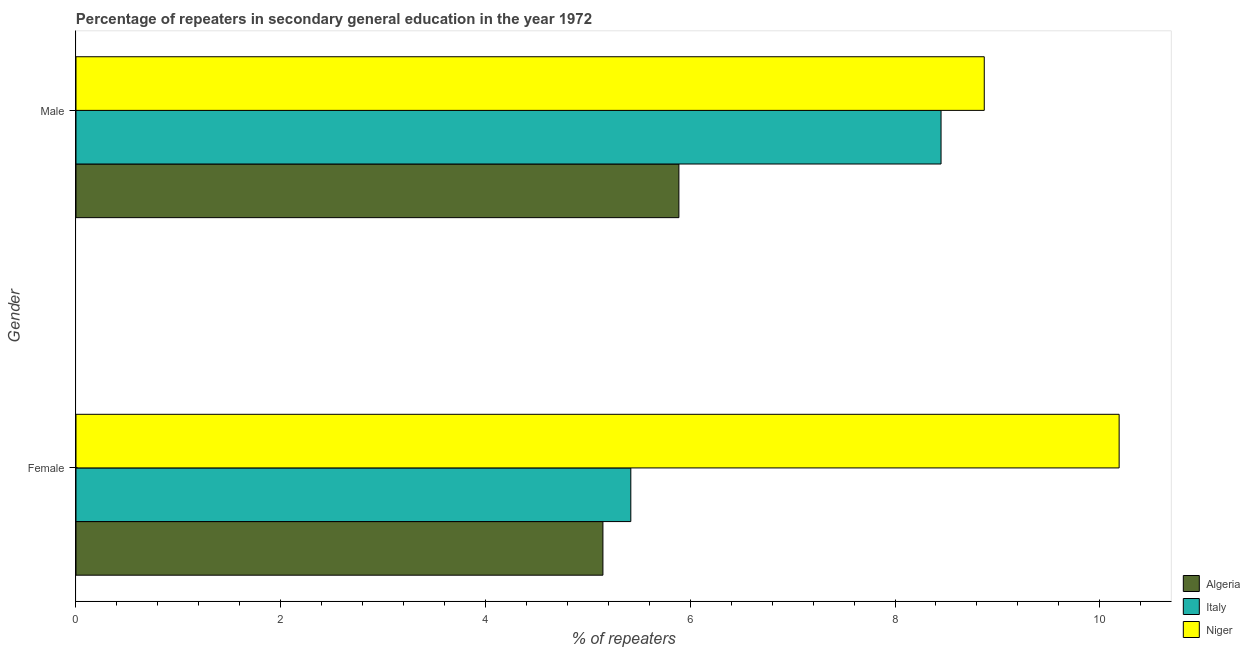Are the number of bars on each tick of the Y-axis equal?
Ensure brevity in your answer.  Yes. How many bars are there on the 1st tick from the top?
Give a very brief answer. 3. What is the percentage of male repeaters in Algeria?
Provide a succinct answer. 5.89. Across all countries, what is the maximum percentage of female repeaters?
Offer a very short reply. 10.19. Across all countries, what is the minimum percentage of male repeaters?
Keep it short and to the point. 5.89. In which country was the percentage of male repeaters maximum?
Keep it short and to the point. Niger. In which country was the percentage of male repeaters minimum?
Provide a short and direct response. Algeria. What is the total percentage of male repeaters in the graph?
Your answer should be compact. 23.21. What is the difference between the percentage of female repeaters in Niger and that in Italy?
Keep it short and to the point. 4.77. What is the difference between the percentage of female repeaters in Niger and the percentage of male repeaters in Italy?
Your answer should be compact. 1.74. What is the average percentage of female repeaters per country?
Your answer should be very brief. 6.92. What is the difference between the percentage of male repeaters and percentage of female repeaters in Italy?
Make the answer very short. 3.03. In how many countries, is the percentage of male repeaters greater than 0.8 %?
Offer a very short reply. 3. What is the ratio of the percentage of female repeaters in Niger to that in Italy?
Keep it short and to the point. 1.88. Is the percentage of female repeaters in Algeria less than that in Niger?
Your response must be concise. Yes. In how many countries, is the percentage of male repeaters greater than the average percentage of male repeaters taken over all countries?
Ensure brevity in your answer.  2. What does the 2nd bar from the top in Female represents?
Ensure brevity in your answer.  Italy. What does the 1st bar from the bottom in Male represents?
Keep it short and to the point. Algeria. How many countries are there in the graph?
Your answer should be very brief. 3. Does the graph contain any zero values?
Offer a very short reply. No. How many legend labels are there?
Your answer should be very brief. 3. How are the legend labels stacked?
Make the answer very short. Vertical. What is the title of the graph?
Make the answer very short. Percentage of repeaters in secondary general education in the year 1972. Does "Switzerland" appear as one of the legend labels in the graph?
Your answer should be very brief. No. What is the label or title of the X-axis?
Provide a succinct answer. % of repeaters. What is the % of repeaters in Algeria in Female?
Your answer should be compact. 5.15. What is the % of repeaters of Italy in Female?
Keep it short and to the point. 5.42. What is the % of repeaters of Niger in Female?
Give a very brief answer. 10.19. What is the % of repeaters of Algeria in Male?
Keep it short and to the point. 5.89. What is the % of repeaters in Italy in Male?
Keep it short and to the point. 8.45. What is the % of repeaters of Niger in Male?
Give a very brief answer. 8.87. Across all Gender, what is the maximum % of repeaters in Algeria?
Your response must be concise. 5.89. Across all Gender, what is the maximum % of repeaters in Italy?
Ensure brevity in your answer.  8.45. Across all Gender, what is the maximum % of repeaters of Niger?
Ensure brevity in your answer.  10.19. Across all Gender, what is the minimum % of repeaters of Algeria?
Keep it short and to the point. 5.15. Across all Gender, what is the minimum % of repeaters in Italy?
Provide a short and direct response. 5.42. Across all Gender, what is the minimum % of repeaters of Niger?
Offer a very short reply. 8.87. What is the total % of repeaters of Algeria in the graph?
Your answer should be compact. 11.04. What is the total % of repeaters of Italy in the graph?
Make the answer very short. 13.87. What is the total % of repeaters of Niger in the graph?
Offer a terse response. 19.06. What is the difference between the % of repeaters of Algeria in Female and that in Male?
Your response must be concise. -0.74. What is the difference between the % of repeaters of Italy in Female and that in Male?
Your answer should be compact. -3.03. What is the difference between the % of repeaters of Niger in Female and that in Male?
Provide a short and direct response. 1.32. What is the difference between the % of repeaters of Algeria in Female and the % of repeaters of Italy in Male?
Give a very brief answer. -3.3. What is the difference between the % of repeaters in Algeria in Female and the % of repeaters in Niger in Male?
Make the answer very short. -3.72. What is the difference between the % of repeaters of Italy in Female and the % of repeaters of Niger in Male?
Your answer should be compact. -3.45. What is the average % of repeaters of Algeria per Gender?
Provide a short and direct response. 5.52. What is the average % of repeaters in Italy per Gender?
Provide a short and direct response. 6.93. What is the average % of repeaters of Niger per Gender?
Give a very brief answer. 9.53. What is the difference between the % of repeaters in Algeria and % of repeaters in Italy in Female?
Your answer should be compact. -0.27. What is the difference between the % of repeaters of Algeria and % of repeaters of Niger in Female?
Give a very brief answer. -5.04. What is the difference between the % of repeaters of Italy and % of repeaters of Niger in Female?
Your answer should be compact. -4.77. What is the difference between the % of repeaters in Algeria and % of repeaters in Italy in Male?
Ensure brevity in your answer.  -2.56. What is the difference between the % of repeaters in Algeria and % of repeaters in Niger in Male?
Your answer should be compact. -2.98. What is the difference between the % of repeaters in Italy and % of repeaters in Niger in Male?
Provide a succinct answer. -0.42. What is the ratio of the % of repeaters of Algeria in Female to that in Male?
Give a very brief answer. 0.87. What is the ratio of the % of repeaters of Italy in Female to that in Male?
Provide a succinct answer. 0.64. What is the ratio of the % of repeaters of Niger in Female to that in Male?
Offer a very short reply. 1.15. What is the difference between the highest and the second highest % of repeaters in Algeria?
Offer a very short reply. 0.74. What is the difference between the highest and the second highest % of repeaters of Italy?
Ensure brevity in your answer.  3.03. What is the difference between the highest and the second highest % of repeaters in Niger?
Your answer should be very brief. 1.32. What is the difference between the highest and the lowest % of repeaters in Algeria?
Your response must be concise. 0.74. What is the difference between the highest and the lowest % of repeaters in Italy?
Your response must be concise. 3.03. What is the difference between the highest and the lowest % of repeaters of Niger?
Offer a very short reply. 1.32. 